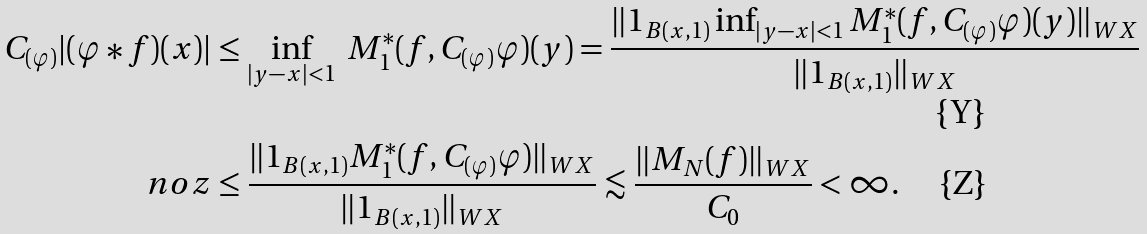<formula> <loc_0><loc_0><loc_500><loc_500>C _ { ( \varphi ) } | ( \varphi \ast f ) ( x ) | & \leq \inf _ { | y - x | < 1 } \ M _ { 1 } ^ { * } ( f , C _ { ( \varphi ) } \varphi ) ( y ) = \frac { \| 1 _ { B ( x , 1 ) } \inf _ { | y - x | < 1 } M _ { 1 } ^ { * } ( f , C _ { ( \varphi ) } \varphi ) ( y ) \| _ { W X } } { \| 1 _ { B ( x , 1 ) } \| _ { W X } } \\ \ n o z & \leq \frac { \| 1 _ { B ( x , 1 ) } M _ { 1 } ^ { * } ( f , C _ { ( \varphi ) } \varphi ) \| _ { W X } } { \| 1 _ { B ( x , 1 ) } \| _ { W X } } \lesssim \frac { \| M _ { N } ( f ) \| _ { W X } } { C _ { 0 } } < \infty .</formula> 